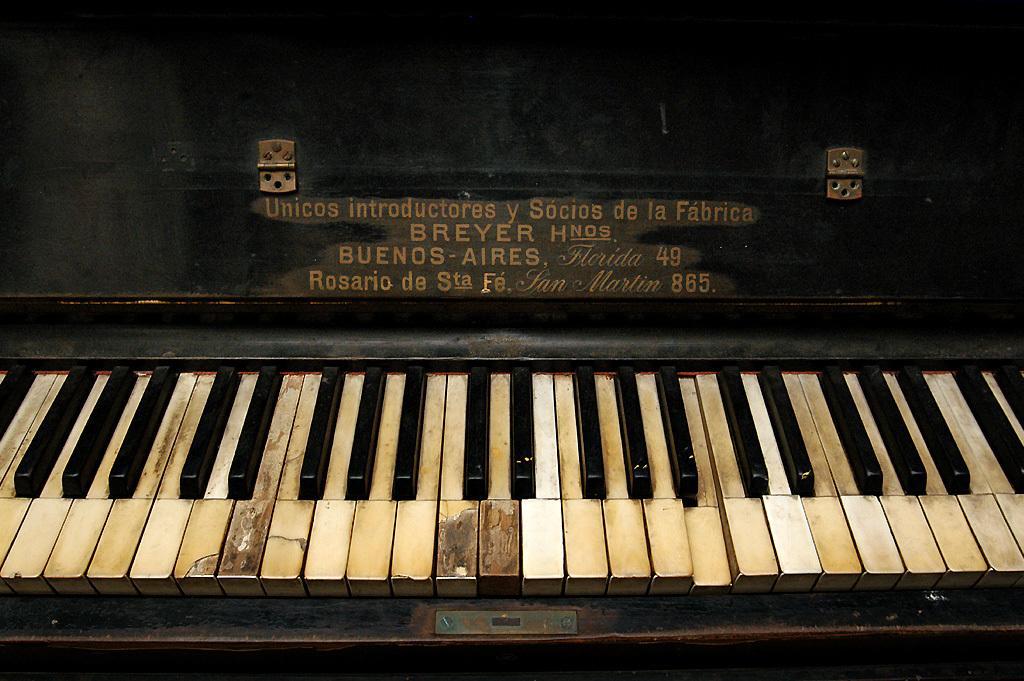Describe this image in one or two sentences. A piano keyboard is highlighted in this picture. 